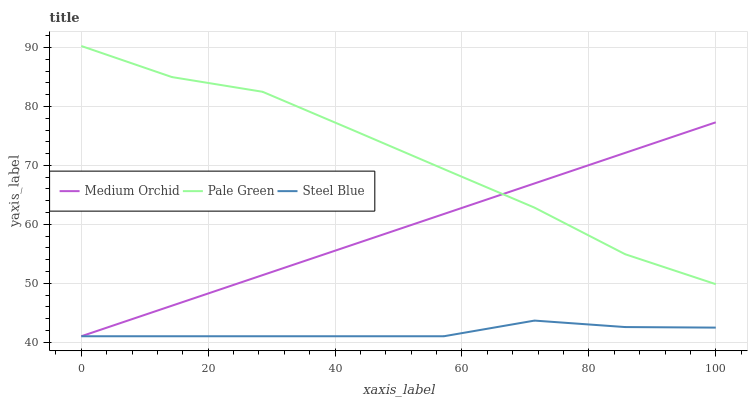Does Medium Orchid have the minimum area under the curve?
Answer yes or no. No. Does Medium Orchid have the maximum area under the curve?
Answer yes or no. No. Is Steel Blue the smoothest?
Answer yes or no. No. Is Steel Blue the roughest?
Answer yes or no. No. Does Medium Orchid have the highest value?
Answer yes or no. No. Is Steel Blue less than Pale Green?
Answer yes or no. Yes. Is Pale Green greater than Steel Blue?
Answer yes or no. Yes. Does Steel Blue intersect Pale Green?
Answer yes or no. No. 